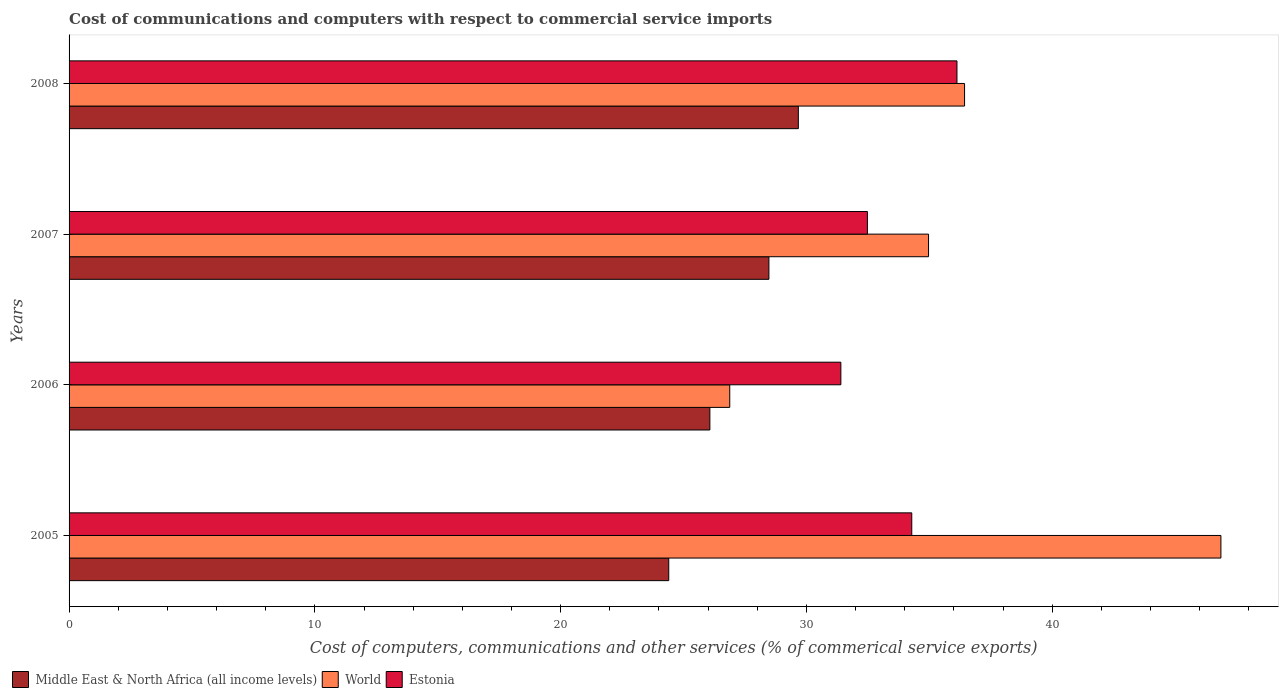Are the number of bars per tick equal to the number of legend labels?
Provide a succinct answer. Yes. Are the number of bars on each tick of the Y-axis equal?
Give a very brief answer. Yes. How many bars are there on the 4th tick from the top?
Your answer should be very brief. 3. What is the label of the 4th group of bars from the top?
Make the answer very short. 2005. What is the cost of communications and computers in Estonia in 2006?
Your answer should be very brief. 31.4. Across all years, what is the maximum cost of communications and computers in Middle East & North Africa (all income levels)?
Provide a succinct answer. 29.67. Across all years, what is the minimum cost of communications and computers in World?
Ensure brevity in your answer.  26.88. In which year was the cost of communications and computers in Middle East & North Africa (all income levels) minimum?
Your answer should be very brief. 2005. What is the total cost of communications and computers in World in the graph?
Your answer should be very brief. 145.14. What is the difference between the cost of communications and computers in World in 2006 and that in 2007?
Offer a terse response. -8.09. What is the difference between the cost of communications and computers in Middle East & North Africa (all income levels) in 2006 and the cost of communications and computers in World in 2005?
Your response must be concise. -20.79. What is the average cost of communications and computers in Middle East & North Africa (all income levels) per year?
Provide a succinct answer. 27.15. In the year 2006, what is the difference between the cost of communications and computers in Middle East & North Africa (all income levels) and cost of communications and computers in Estonia?
Ensure brevity in your answer.  -5.33. In how many years, is the cost of communications and computers in World greater than 24 %?
Your answer should be very brief. 4. What is the ratio of the cost of communications and computers in Middle East & North Africa (all income levels) in 2007 to that in 2008?
Make the answer very short. 0.96. What is the difference between the highest and the second highest cost of communications and computers in World?
Make the answer very short. 10.43. What is the difference between the highest and the lowest cost of communications and computers in Middle East & North Africa (all income levels)?
Give a very brief answer. 5.27. In how many years, is the cost of communications and computers in Estonia greater than the average cost of communications and computers in Estonia taken over all years?
Provide a succinct answer. 2. What does the 3rd bar from the top in 2007 represents?
Ensure brevity in your answer.  Middle East & North Africa (all income levels). What does the 1st bar from the bottom in 2005 represents?
Give a very brief answer. Middle East & North Africa (all income levels). How many bars are there?
Your response must be concise. 12. Are all the bars in the graph horizontal?
Your answer should be very brief. Yes. Does the graph contain any zero values?
Ensure brevity in your answer.  No. Where does the legend appear in the graph?
Your response must be concise. Bottom left. How many legend labels are there?
Offer a very short reply. 3. How are the legend labels stacked?
Keep it short and to the point. Horizontal. What is the title of the graph?
Provide a succinct answer. Cost of communications and computers with respect to commercial service imports. Does "Indonesia" appear as one of the legend labels in the graph?
Offer a terse response. No. What is the label or title of the X-axis?
Ensure brevity in your answer.  Cost of computers, communications and other services (% of commerical service exports). What is the label or title of the Y-axis?
Offer a terse response. Years. What is the Cost of computers, communications and other services (% of commerical service exports) in Middle East & North Africa (all income levels) in 2005?
Make the answer very short. 24.4. What is the Cost of computers, communications and other services (% of commerical service exports) in World in 2005?
Your response must be concise. 46.86. What is the Cost of computers, communications and other services (% of commerical service exports) in Estonia in 2005?
Your answer should be compact. 34.28. What is the Cost of computers, communications and other services (% of commerical service exports) of Middle East & North Africa (all income levels) in 2006?
Provide a succinct answer. 26.07. What is the Cost of computers, communications and other services (% of commerical service exports) in World in 2006?
Provide a short and direct response. 26.88. What is the Cost of computers, communications and other services (% of commerical service exports) in Estonia in 2006?
Offer a terse response. 31.4. What is the Cost of computers, communications and other services (% of commerical service exports) in Middle East & North Africa (all income levels) in 2007?
Give a very brief answer. 28.47. What is the Cost of computers, communications and other services (% of commerical service exports) in World in 2007?
Ensure brevity in your answer.  34.97. What is the Cost of computers, communications and other services (% of commerical service exports) in Estonia in 2007?
Keep it short and to the point. 32.48. What is the Cost of computers, communications and other services (% of commerical service exports) in Middle East & North Africa (all income levels) in 2008?
Offer a terse response. 29.67. What is the Cost of computers, communications and other services (% of commerical service exports) in World in 2008?
Provide a short and direct response. 36.43. What is the Cost of computers, communications and other services (% of commerical service exports) in Estonia in 2008?
Ensure brevity in your answer.  36.12. Across all years, what is the maximum Cost of computers, communications and other services (% of commerical service exports) of Middle East & North Africa (all income levels)?
Your response must be concise. 29.67. Across all years, what is the maximum Cost of computers, communications and other services (% of commerical service exports) in World?
Keep it short and to the point. 46.86. Across all years, what is the maximum Cost of computers, communications and other services (% of commerical service exports) in Estonia?
Your response must be concise. 36.12. Across all years, what is the minimum Cost of computers, communications and other services (% of commerical service exports) of Middle East & North Africa (all income levels)?
Offer a very short reply. 24.4. Across all years, what is the minimum Cost of computers, communications and other services (% of commerical service exports) in World?
Keep it short and to the point. 26.88. Across all years, what is the minimum Cost of computers, communications and other services (% of commerical service exports) in Estonia?
Ensure brevity in your answer.  31.4. What is the total Cost of computers, communications and other services (% of commerical service exports) of Middle East & North Africa (all income levels) in the graph?
Offer a very short reply. 108.61. What is the total Cost of computers, communications and other services (% of commerical service exports) of World in the graph?
Your answer should be very brief. 145.14. What is the total Cost of computers, communications and other services (% of commerical service exports) of Estonia in the graph?
Offer a terse response. 134.29. What is the difference between the Cost of computers, communications and other services (% of commerical service exports) of Middle East & North Africa (all income levels) in 2005 and that in 2006?
Ensure brevity in your answer.  -1.67. What is the difference between the Cost of computers, communications and other services (% of commerical service exports) in World in 2005 and that in 2006?
Your answer should be very brief. 19.98. What is the difference between the Cost of computers, communications and other services (% of commerical service exports) in Estonia in 2005 and that in 2006?
Keep it short and to the point. 2.88. What is the difference between the Cost of computers, communications and other services (% of commerical service exports) in Middle East & North Africa (all income levels) in 2005 and that in 2007?
Keep it short and to the point. -4.07. What is the difference between the Cost of computers, communications and other services (% of commerical service exports) in World in 2005 and that in 2007?
Offer a terse response. 11.89. What is the difference between the Cost of computers, communications and other services (% of commerical service exports) of Estonia in 2005 and that in 2007?
Ensure brevity in your answer.  1.8. What is the difference between the Cost of computers, communications and other services (% of commerical service exports) in Middle East & North Africa (all income levels) in 2005 and that in 2008?
Offer a terse response. -5.27. What is the difference between the Cost of computers, communications and other services (% of commerical service exports) in World in 2005 and that in 2008?
Offer a very short reply. 10.43. What is the difference between the Cost of computers, communications and other services (% of commerical service exports) of Estonia in 2005 and that in 2008?
Make the answer very short. -1.84. What is the difference between the Cost of computers, communications and other services (% of commerical service exports) in Middle East & North Africa (all income levels) in 2006 and that in 2007?
Ensure brevity in your answer.  -2.4. What is the difference between the Cost of computers, communications and other services (% of commerical service exports) in World in 2006 and that in 2007?
Provide a succinct answer. -8.09. What is the difference between the Cost of computers, communications and other services (% of commerical service exports) of Estonia in 2006 and that in 2007?
Offer a very short reply. -1.08. What is the difference between the Cost of computers, communications and other services (% of commerical service exports) of Middle East & North Africa (all income levels) in 2006 and that in 2008?
Your answer should be compact. -3.6. What is the difference between the Cost of computers, communications and other services (% of commerical service exports) in World in 2006 and that in 2008?
Offer a terse response. -9.55. What is the difference between the Cost of computers, communications and other services (% of commerical service exports) of Estonia in 2006 and that in 2008?
Your response must be concise. -4.72. What is the difference between the Cost of computers, communications and other services (% of commerical service exports) of Middle East & North Africa (all income levels) in 2007 and that in 2008?
Offer a very short reply. -1.2. What is the difference between the Cost of computers, communications and other services (% of commerical service exports) in World in 2007 and that in 2008?
Give a very brief answer. -1.47. What is the difference between the Cost of computers, communications and other services (% of commerical service exports) of Estonia in 2007 and that in 2008?
Your response must be concise. -3.64. What is the difference between the Cost of computers, communications and other services (% of commerical service exports) in Middle East & North Africa (all income levels) in 2005 and the Cost of computers, communications and other services (% of commerical service exports) in World in 2006?
Your answer should be compact. -2.48. What is the difference between the Cost of computers, communications and other services (% of commerical service exports) of Middle East & North Africa (all income levels) in 2005 and the Cost of computers, communications and other services (% of commerical service exports) of Estonia in 2006?
Your answer should be very brief. -7. What is the difference between the Cost of computers, communications and other services (% of commerical service exports) in World in 2005 and the Cost of computers, communications and other services (% of commerical service exports) in Estonia in 2006?
Provide a succinct answer. 15.46. What is the difference between the Cost of computers, communications and other services (% of commerical service exports) of Middle East & North Africa (all income levels) in 2005 and the Cost of computers, communications and other services (% of commerical service exports) of World in 2007?
Provide a short and direct response. -10.57. What is the difference between the Cost of computers, communications and other services (% of commerical service exports) of Middle East & North Africa (all income levels) in 2005 and the Cost of computers, communications and other services (% of commerical service exports) of Estonia in 2007?
Ensure brevity in your answer.  -8.08. What is the difference between the Cost of computers, communications and other services (% of commerical service exports) in World in 2005 and the Cost of computers, communications and other services (% of commerical service exports) in Estonia in 2007?
Keep it short and to the point. 14.38. What is the difference between the Cost of computers, communications and other services (% of commerical service exports) of Middle East & North Africa (all income levels) in 2005 and the Cost of computers, communications and other services (% of commerical service exports) of World in 2008?
Keep it short and to the point. -12.04. What is the difference between the Cost of computers, communications and other services (% of commerical service exports) in Middle East & North Africa (all income levels) in 2005 and the Cost of computers, communications and other services (% of commerical service exports) in Estonia in 2008?
Offer a terse response. -11.73. What is the difference between the Cost of computers, communications and other services (% of commerical service exports) of World in 2005 and the Cost of computers, communications and other services (% of commerical service exports) of Estonia in 2008?
Offer a terse response. 10.74. What is the difference between the Cost of computers, communications and other services (% of commerical service exports) of Middle East & North Africa (all income levels) in 2006 and the Cost of computers, communications and other services (% of commerical service exports) of World in 2007?
Provide a short and direct response. -8.9. What is the difference between the Cost of computers, communications and other services (% of commerical service exports) in Middle East & North Africa (all income levels) in 2006 and the Cost of computers, communications and other services (% of commerical service exports) in Estonia in 2007?
Provide a succinct answer. -6.41. What is the difference between the Cost of computers, communications and other services (% of commerical service exports) of World in 2006 and the Cost of computers, communications and other services (% of commerical service exports) of Estonia in 2007?
Make the answer very short. -5.6. What is the difference between the Cost of computers, communications and other services (% of commerical service exports) of Middle East & North Africa (all income levels) in 2006 and the Cost of computers, communications and other services (% of commerical service exports) of World in 2008?
Provide a succinct answer. -10.36. What is the difference between the Cost of computers, communications and other services (% of commerical service exports) of Middle East & North Africa (all income levels) in 2006 and the Cost of computers, communications and other services (% of commerical service exports) of Estonia in 2008?
Provide a short and direct response. -10.05. What is the difference between the Cost of computers, communications and other services (% of commerical service exports) in World in 2006 and the Cost of computers, communications and other services (% of commerical service exports) in Estonia in 2008?
Provide a succinct answer. -9.24. What is the difference between the Cost of computers, communications and other services (% of commerical service exports) of Middle East & North Africa (all income levels) in 2007 and the Cost of computers, communications and other services (% of commerical service exports) of World in 2008?
Keep it short and to the point. -7.96. What is the difference between the Cost of computers, communications and other services (% of commerical service exports) of Middle East & North Africa (all income levels) in 2007 and the Cost of computers, communications and other services (% of commerical service exports) of Estonia in 2008?
Provide a short and direct response. -7.65. What is the difference between the Cost of computers, communications and other services (% of commerical service exports) of World in 2007 and the Cost of computers, communications and other services (% of commerical service exports) of Estonia in 2008?
Ensure brevity in your answer.  -1.16. What is the average Cost of computers, communications and other services (% of commerical service exports) in Middle East & North Africa (all income levels) per year?
Provide a succinct answer. 27.15. What is the average Cost of computers, communications and other services (% of commerical service exports) of World per year?
Your answer should be compact. 36.29. What is the average Cost of computers, communications and other services (% of commerical service exports) in Estonia per year?
Keep it short and to the point. 33.57. In the year 2005, what is the difference between the Cost of computers, communications and other services (% of commerical service exports) of Middle East & North Africa (all income levels) and Cost of computers, communications and other services (% of commerical service exports) of World?
Your answer should be compact. -22.46. In the year 2005, what is the difference between the Cost of computers, communications and other services (% of commerical service exports) of Middle East & North Africa (all income levels) and Cost of computers, communications and other services (% of commerical service exports) of Estonia?
Ensure brevity in your answer.  -9.89. In the year 2005, what is the difference between the Cost of computers, communications and other services (% of commerical service exports) in World and Cost of computers, communications and other services (% of commerical service exports) in Estonia?
Make the answer very short. 12.58. In the year 2006, what is the difference between the Cost of computers, communications and other services (% of commerical service exports) in Middle East & North Africa (all income levels) and Cost of computers, communications and other services (% of commerical service exports) in World?
Your answer should be compact. -0.81. In the year 2006, what is the difference between the Cost of computers, communications and other services (% of commerical service exports) of Middle East & North Africa (all income levels) and Cost of computers, communications and other services (% of commerical service exports) of Estonia?
Make the answer very short. -5.33. In the year 2006, what is the difference between the Cost of computers, communications and other services (% of commerical service exports) in World and Cost of computers, communications and other services (% of commerical service exports) in Estonia?
Your answer should be very brief. -4.52. In the year 2007, what is the difference between the Cost of computers, communications and other services (% of commerical service exports) in Middle East & North Africa (all income levels) and Cost of computers, communications and other services (% of commerical service exports) in World?
Make the answer very short. -6.5. In the year 2007, what is the difference between the Cost of computers, communications and other services (% of commerical service exports) in Middle East & North Africa (all income levels) and Cost of computers, communications and other services (% of commerical service exports) in Estonia?
Your answer should be compact. -4.01. In the year 2007, what is the difference between the Cost of computers, communications and other services (% of commerical service exports) of World and Cost of computers, communications and other services (% of commerical service exports) of Estonia?
Keep it short and to the point. 2.49. In the year 2008, what is the difference between the Cost of computers, communications and other services (% of commerical service exports) in Middle East & North Africa (all income levels) and Cost of computers, communications and other services (% of commerical service exports) in World?
Your answer should be compact. -6.76. In the year 2008, what is the difference between the Cost of computers, communications and other services (% of commerical service exports) of Middle East & North Africa (all income levels) and Cost of computers, communications and other services (% of commerical service exports) of Estonia?
Ensure brevity in your answer.  -6.45. In the year 2008, what is the difference between the Cost of computers, communications and other services (% of commerical service exports) in World and Cost of computers, communications and other services (% of commerical service exports) in Estonia?
Give a very brief answer. 0.31. What is the ratio of the Cost of computers, communications and other services (% of commerical service exports) of Middle East & North Africa (all income levels) in 2005 to that in 2006?
Your answer should be compact. 0.94. What is the ratio of the Cost of computers, communications and other services (% of commerical service exports) of World in 2005 to that in 2006?
Give a very brief answer. 1.74. What is the ratio of the Cost of computers, communications and other services (% of commerical service exports) in Estonia in 2005 to that in 2006?
Your answer should be very brief. 1.09. What is the ratio of the Cost of computers, communications and other services (% of commerical service exports) of Middle East & North Africa (all income levels) in 2005 to that in 2007?
Give a very brief answer. 0.86. What is the ratio of the Cost of computers, communications and other services (% of commerical service exports) of World in 2005 to that in 2007?
Give a very brief answer. 1.34. What is the ratio of the Cost of computers, communications and other services (% of commerical service exports) of Estonia in 2005 to that in 2007?
Make the answer very short. 1.06. What is the ratio of the Cost of computers, communications and other services (% of commerical service exports) in Middle East & North Africa (all income levels) in 2005 to that in 2008?
Your answer should be very brief. 0.82. What is the ratio of the Cost of computers, communications and other services (% of commerical service exports) in World in 2005 to that in 2008?
Provide a short and direct response. 1.29. What is the ratio of the Cost of computers, communications and other services (% of commerical service exports) in Estonia in 2005 to that in 2008?
Provide a succinct answer. 0.95. What is the ratio of the Cost of computers, communications and other services (% of commerical service exports) in Middle East & North Africa (all income levels) in 2006 to that in 2007?
Make the answer very short. 0.92. What is the ratio of the Cost of computers, communications and other services (% of commerical service exports) in World in 2006 to that in 2007?
Your response must be concise. 0.77. What is the ratio of the Cost of computers, communications and other services (% of commerical service exports) in Estonia in 2006 to that in 2007?
Make the answer very short. 0.97. What is the ratio of the Cost of computers, communications and other services (% of commerical service exports) in Middle East & North Africa (all income levels) in 2006 to that in 2008?
Provide a succinct answer. 0.88. What is the ratio of the Cost of computers, communications and other services (% of commerical service exports) of World in 2006 to that in 2008?
Provide a short and direct response. 0.74. What is the ratio of the Cost of computers, communications and other services (% of commerical service exports) of Estonia in 2006 to that in 2008?
Provide a succinct answer. 0.87. What is the ratio of the Cost of computers, communications and other services (% of commerical service exports) of Middle East & North Africa (all income levels) in 2007 to that in 2008?
Your answer should be very brief. 0.96. What is the ratio of the Cost of computers, communications and other services (% of commerical service exports) of World in 2007 to that in 2008?
Your answer should be compact. 0.96. What is the ratio of the Cost of computers, communications and other services (% of commerical service exports) in Estonia in 2007 to that in 2008?
Offer a terse response. 0.9. What is the difference between the highest and the second highest Cost of computers, communications and other services (% of commerical service exports) in Middle East & North Africa (all income levels)?
Offer a very short reply. 1.2. What is the difference between the highest and the second highest Cost of computers, communications and other services (% of commerical service exports) in World?
Your answer should be very brief. 10.43. What is the difference between the highest and the second highest Cost of computers, communications and other services (% of commerical service exports) in Estonia?
Keep it short and to the point. 1.84. What is the difference between the highest and the lowest Cost of computers, communications and other services (% of commerical service exports) of Middle East & North Africa (all income levels)?
Offer a very short reply. 5.27. What is the difference between the highest and the lowest Cost of computers, communications and other services (% of commerical service exports) in World?
Your response must be concise. 19.98. What is the difference between the highest and the lowest Cost of computers, communications and other services (% of commerical service exports) of Estonia?
Your answer should be compact. 4.72. 